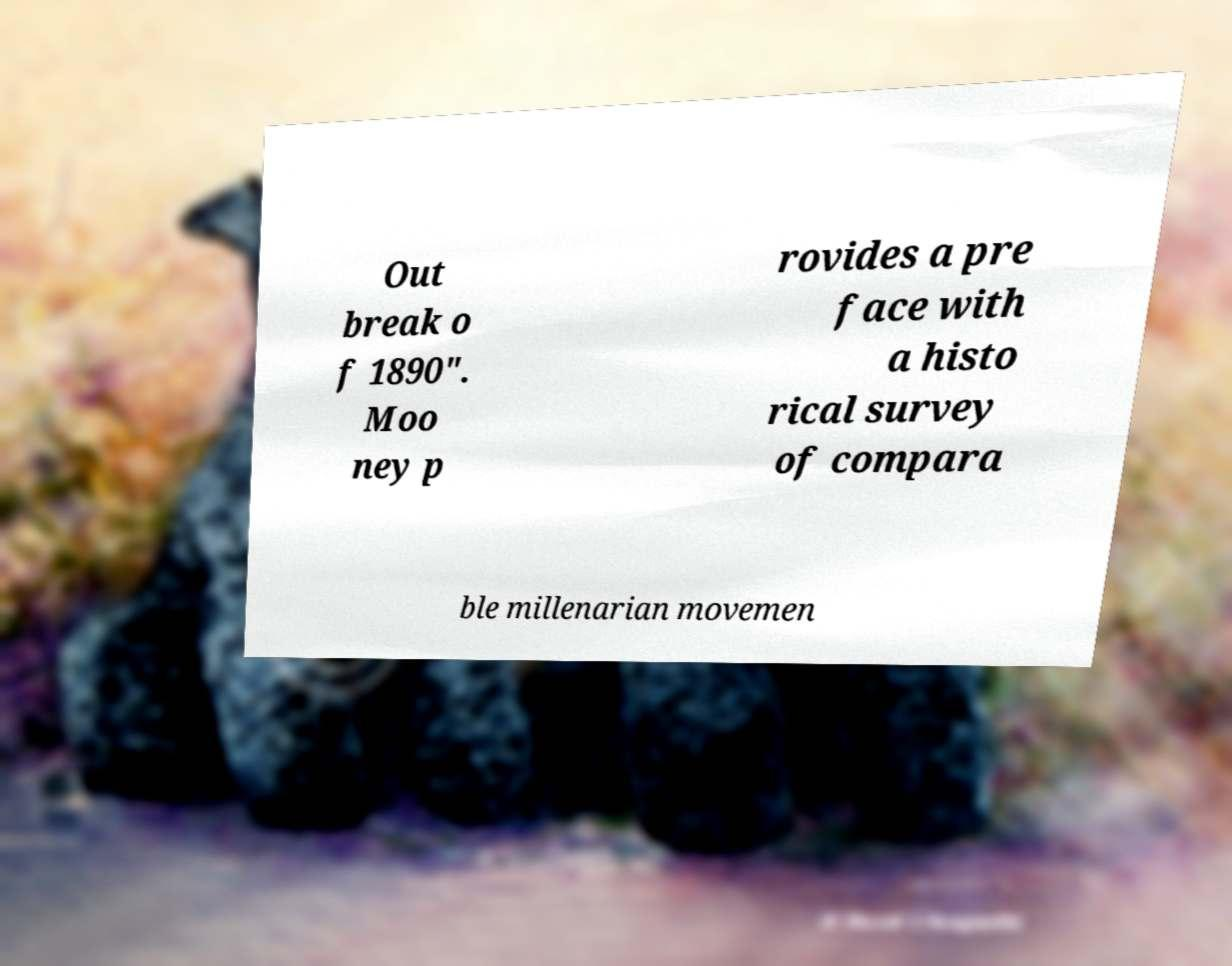What messages or text are displayed in this image? I need them in a readable, typed format. Out break o f 1890". Moo ney p rovides a pre face with a histo rical survey of compara ble millenarian movemen 